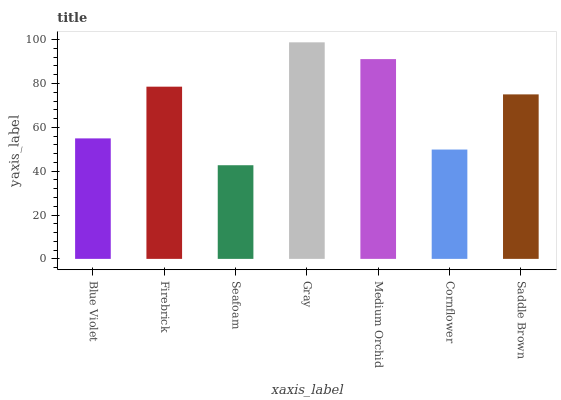Is Seafoam the minimum?
Answer yes or no. Yes. Is Gray the maximum?
Answer yes or no. Yes. Is Firebrick the minimum?
Answer yes or no. No. Is Firebrick the maximum?
Answer yes or no. No. Is Firebrick greater than Blue Violet?
Answer yes or no. Yes. Is Blue Violet less than Firebrick?
Answer yes or no. Yes. Is Blue Violet greater than Firebrick?
Answer yes or no. No. Is Firebrick less than Blue Violet?
Answer yes or no. No. Is Saddle Brown the high median?
Answer yes or no. Yes. Is Saddle Brown the low median?
Answer yes or no. Yes. Is Firebrick the high median?
Answer yes or no. No. Is Blue Violet the low median?
Answer yes or no. No. 